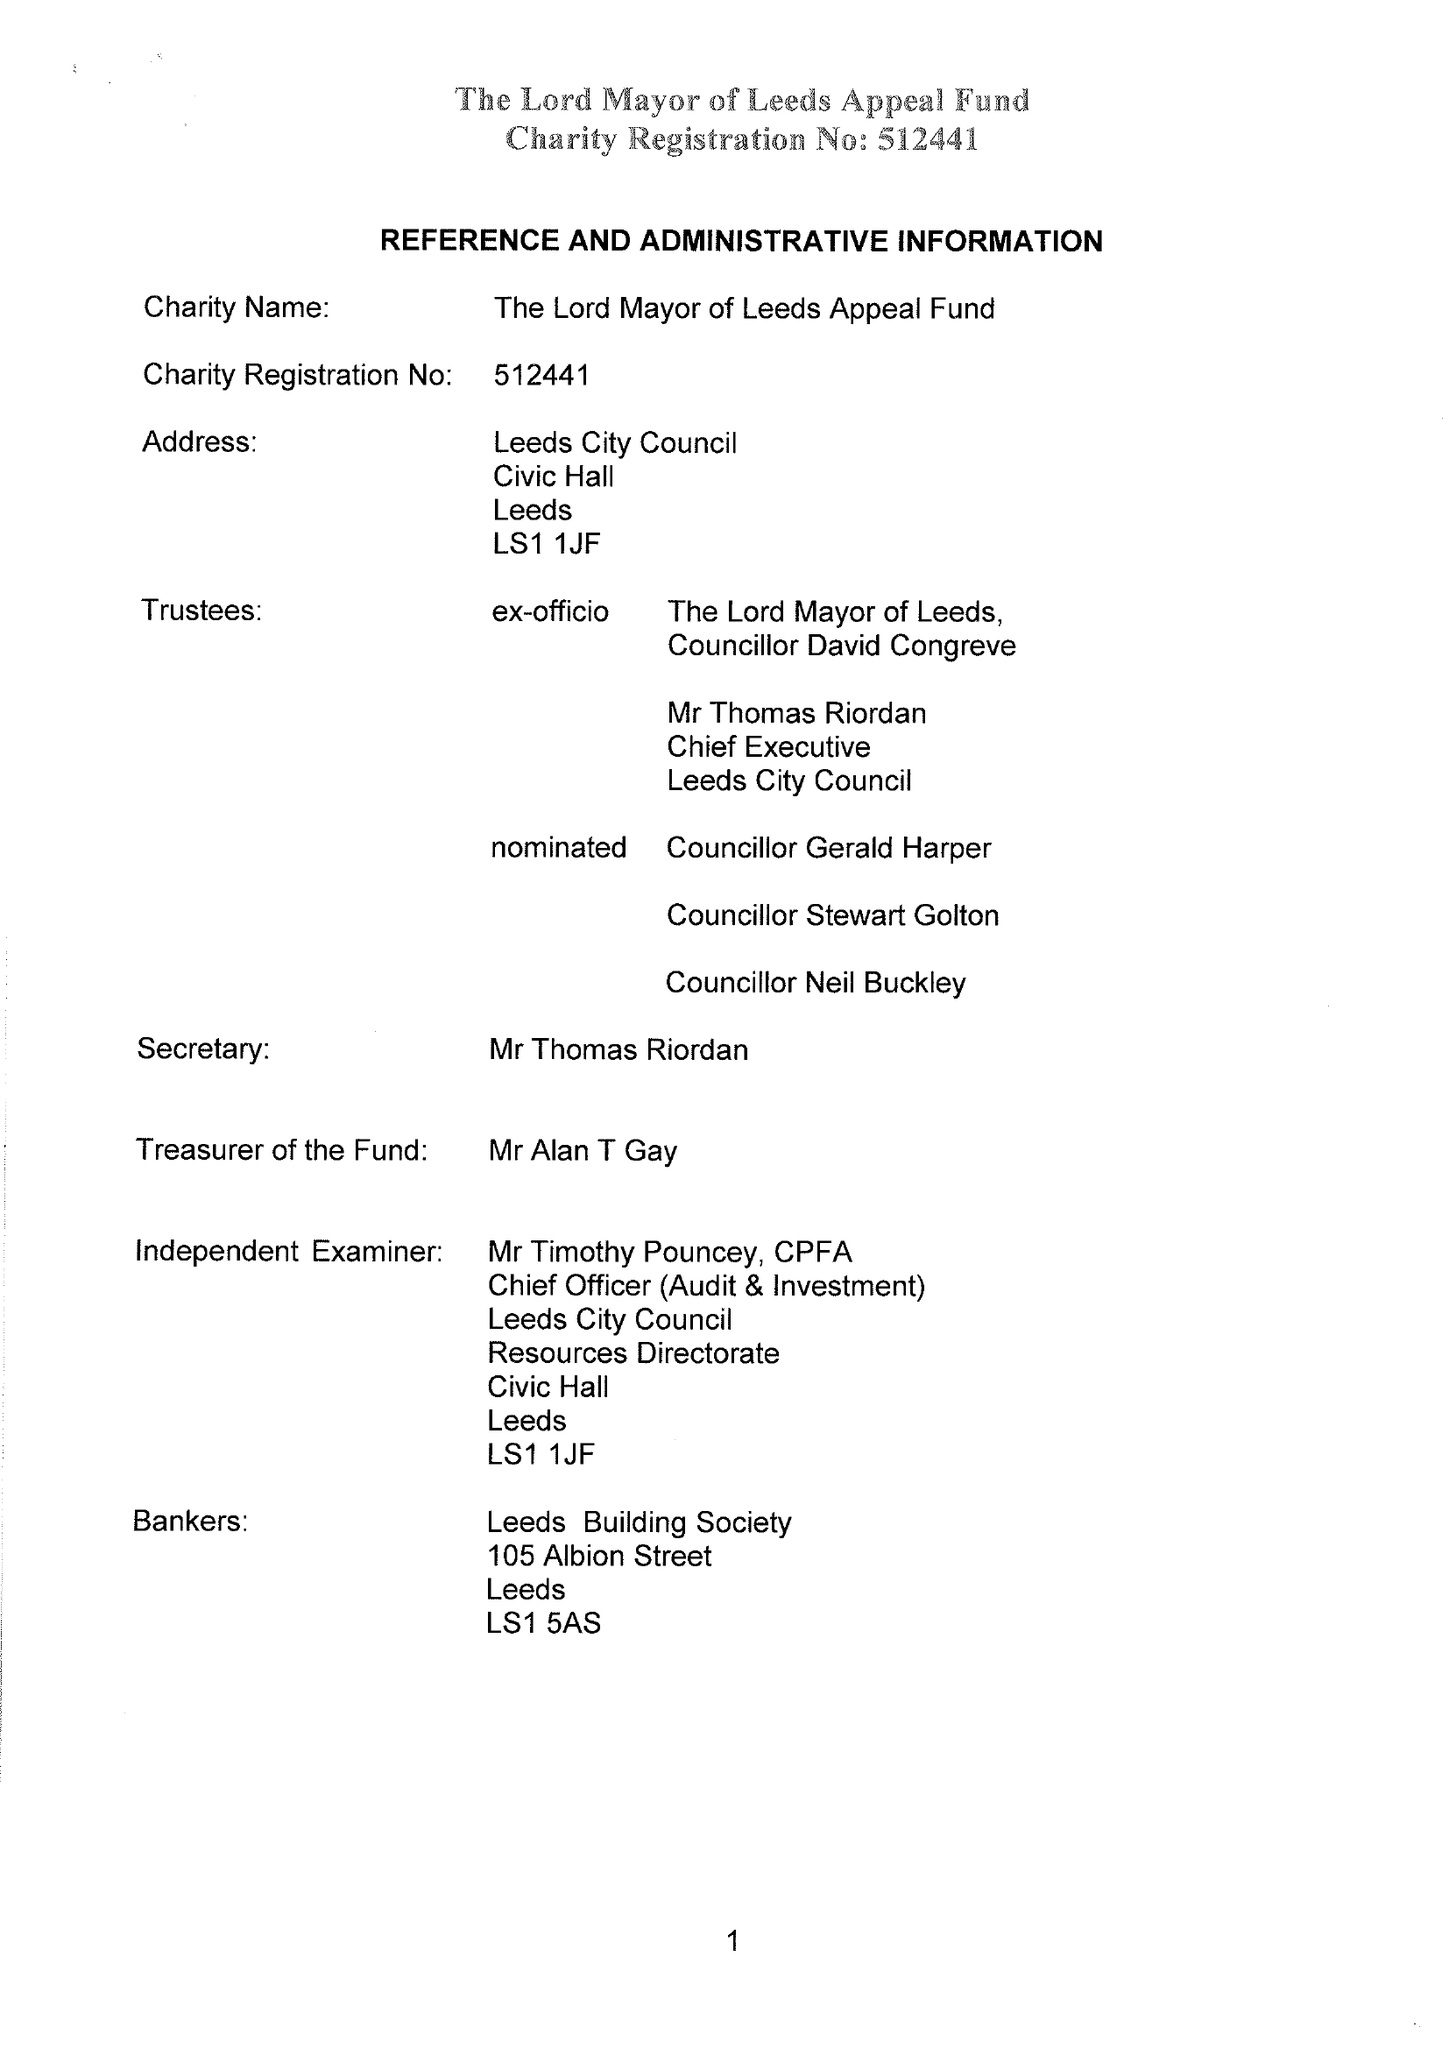What is the value for the report_date?
Answer the question using a single word or phrase. 2015-05-31 